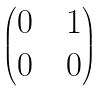<formula> <loc_0><loc_0><loc_500><loc_500>\begin{pmatrix} 0 & & 1 \\ 0 & & 0 \end{pmatrix}</formula> 